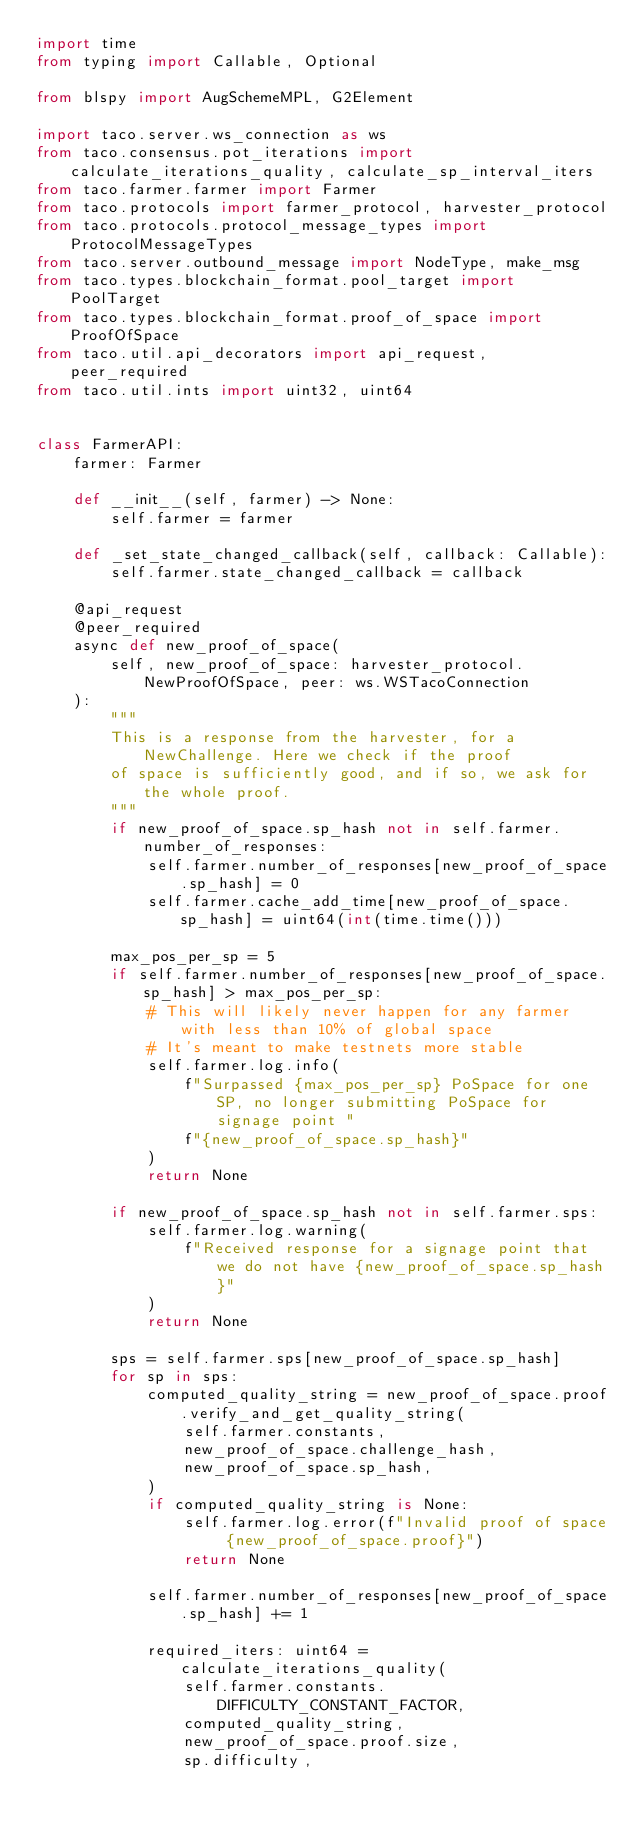Convert code to text. <code><loc_0><loc_0><loc_500><loc_500><_Python_>import time
from typing import Callable, Optional

from blspy import AugSchemeMPL, G2Element

import taco.server.ws_connection as ws
from taco.consensus.pot_iterations import calculate_iterations_quality, calculate_sp_interval_iters
from taco.farmer.farmer import Farmer
from taco.protocols import farmer_protocol, harvester_protocol
from taco.protocols.protocol_message_types import ProtocolMessageTypes
from taco.server.outbound_message import NodeType, make_msg
from taco.types.blockchain_format.pool_target import PoolTarget
from taco.types.blockchain_format.proof_of_space import ProofOfSpace
from taco.util.api_decorators import api_request, peer_required
from taco.util.ints import uint32, uint64


class FarmerAPI:
    farmer: Farmer

    def __init__(self, farmer) -> None:
        self.farmer = farmer

    def _set_state_changed_callback(self, callback: Callable):
        self.farmer.state_changed_callback = callback

    @api_request
    @peer_required
    async def new_proof_of_space(
        self, new_proof_of_space: harvester_protocol.NewProofOfSpace, peer: ws.WSTacoConnection
    ):
        """
        This is a response from the harvester, for a NewChallenge. Here we check if the proof
        of space is sufficiently good, and if so, we ask for the whole proof.
        """
        if new_proof_of_space.sp_hash not in self.farmer.number_of_responses:
            self.farmer.number_of_responses[new_proof_of_space.sp_hash] = 0
            self.farmer.cache_add_time[new_proof_of_space.sp_hash] = uint64(int(time.time()))

        max_pos_per_sp = 5
        if self.farmer.number_of_responses[new_proof_of_space.sp_hash] > max_pos_per_sp:
            # This will likely never happen for any farmer with less than 10% of global space
            # It's meant to make testnets more stable
            self.farmer.log.info(
                f"Surpassed {max_pos_per_sp} PoSpace for one SP, no longer submitting PoSpace for signage point "
                f"{new_proof_of_space.sp_hash}"
            )
            return None

        if new_proof_of_space.sp_hash not in self.farmer.sps:
            self.farmer.log.warning(
                f"Received response for a signage point that we do not have {new_proof_of_space.sp_hash}"
            )
            return None

        sps = self.farmer.sps[new_proof_of_space.sp_hash]
        for sp in sps:
            computed_quality_string = new_proof_of_space.proof.verify_and_get_quality_string(
                self.farmer.constants,
                new_proof_of_space.challenge_hash,
                new_proof_of_space.sp_hash,
            )
            if computed_quality_string is None:
                self.farmer.log.error(f"Invalid proof of space {new_proof_of_space.proof}")
                return None

            self.farmer.number_of_responses[new_proof_of_space.sp_hash] += 1

            required_iters: uint64 = calculate_iterations_quality(
                self.farmer.constants.DIFFICULTY_CONSTANT_FACTOR,
                computed_quality_string,
                new_proof_of_space.proof.size,
                sp.difficulty,</code> 